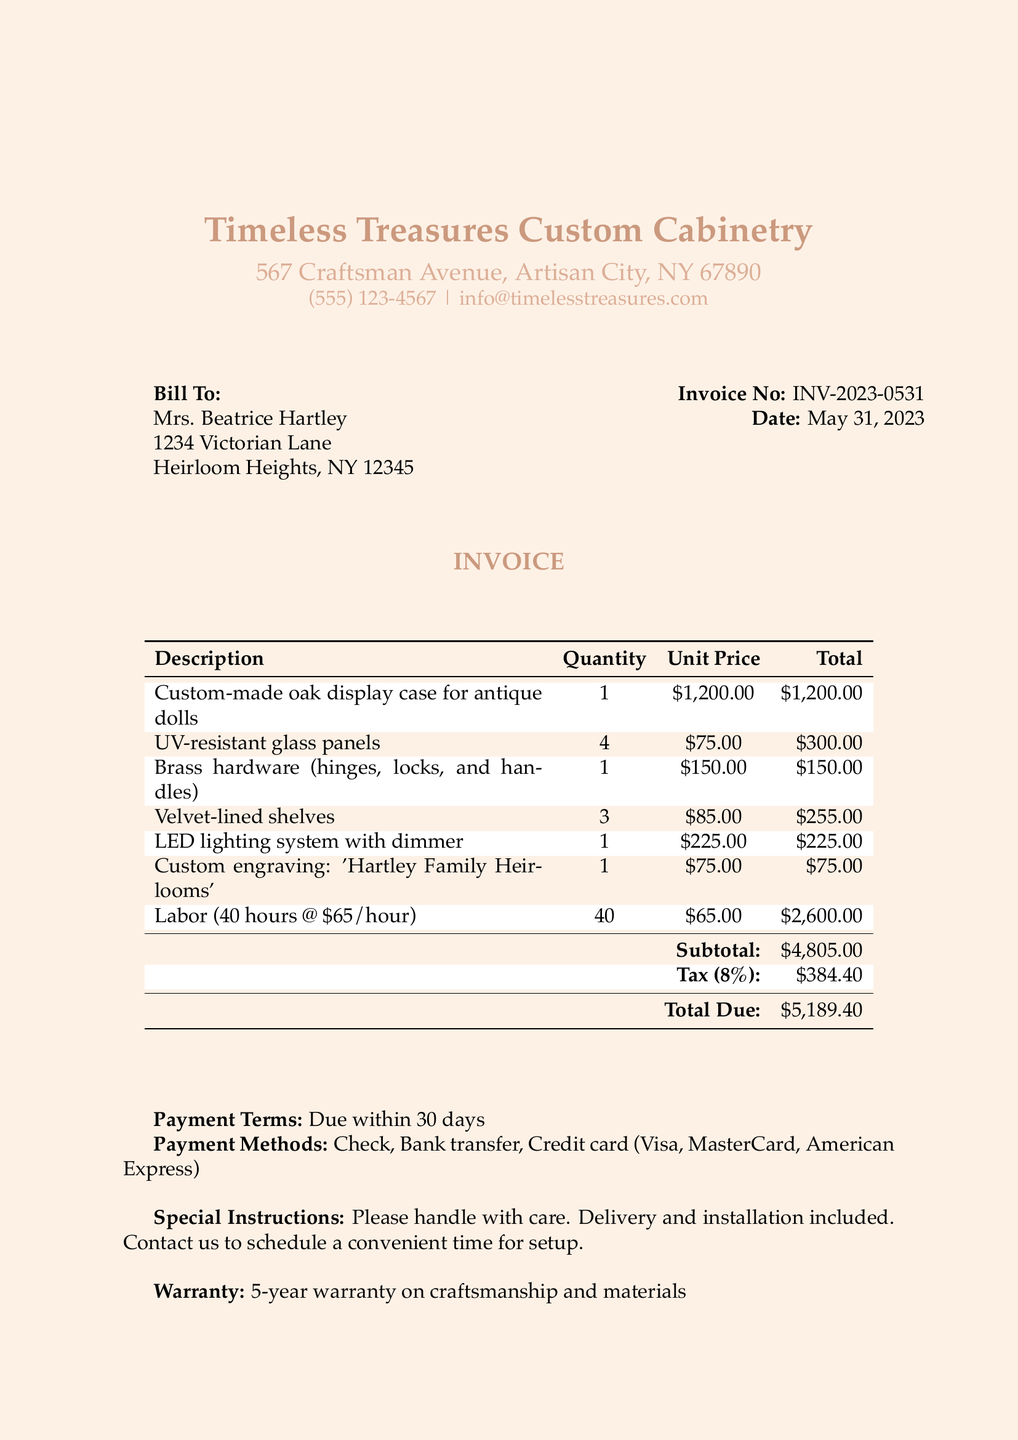What is the invoice number? The invoice number is specifically mentioned at the top of the document.
Answer: INV-2023-0531 Who is the customer? The customer is identified at the beginning of the invoice.
Answer: Mrs. Beatrice Hartley What is the total due amount? The total due is found at the bottom of the invoice, summarizing all charges.
Answer: $5,189.40 How many LED lighting systems were included? This quantity is listed in the table of items on the invoice.
Answer: 1 What is the labor cost per hour? The labor cost is detailed in the invoice under the labor section.
Answer: $65.00 What is included with the purchase as special instructions? The special instructions provide guidance regarding the handling and setup of the item.
Answer: Delivery and installation included What is the warranty period for this custom case? The warranty offered is specifically stated in the document.
Answer: 5-year warranty What is the tax rate applied to the subtotal? The tax rate is clearly stated in the invoice and is applied to the subtotal.
Answer: 8% What engraving was requested on the display case? The specific engraving is mentioned in the itemized list.
Answer: 'Hartley Family Heirlooms' 